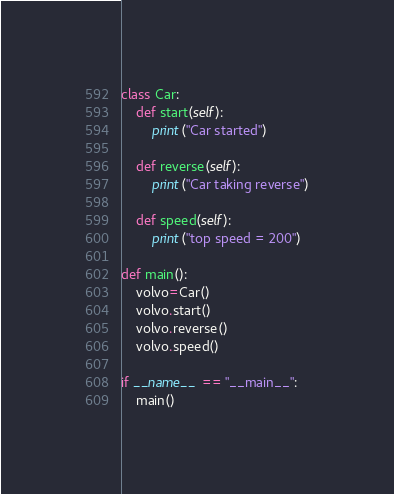<code> <loc_0><loc_0><loc_500><loc_500><_Python_>class Car:
    def start(self):
        print("Car started")
	
    def reverse(self):
        print("Car taking reverse")
		
    def speed(self):
	    print("top speed = 200")

def main():
    volvo=Car()
    volvo.start()
    volvo.reverse()
    volvo.speed()
   
if __name__ == "__main__":
    main()</code> 